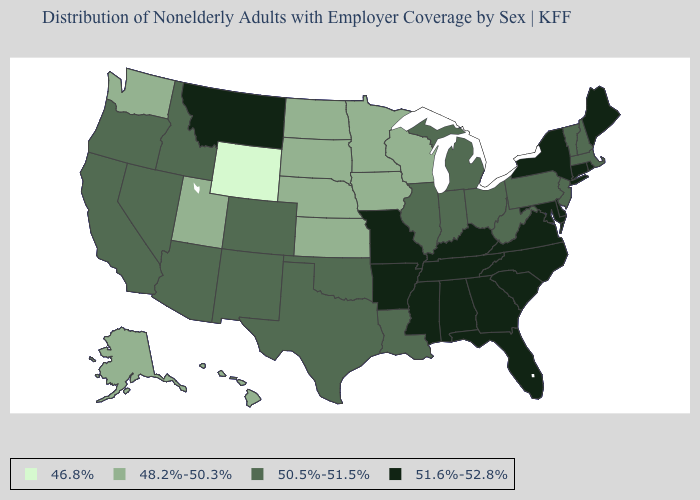Among the states that border Illinois , which have the lowest value?
Short answer required. Iowa, Wisconsin. Name the states that have a value in the range 51.6%-52.8%?
Short answer required. Alabama, Arkansas, Connecticut, Delaware, Florida, Georgia, Kentucky, Maine, Maryland, Mississippi, Missouri, Montana, New York, North Carolina, Rhode Island, South Carolina, Tennessee, Virginia. Among the states that border Virginia , does Maryland have the lowest value?
Be succinct. No. Is the legend a continuous bar?
Concise answer only. No. Does Maine have the lowest value in the Northeast?
Give a very brief answer. No. Among the states that border Virginia , which have the highest value?
Give a very brief answer. Kentucky, Maryland, North Carolina, Tennessee. Which states have the lowest value in the USA?
Be succinct. Wyoming. Name the states that have a value in the range 48.2%-50.3%?
Short answer required. Alaska, Hawaii, Iowa, Kansas, Minnesota, Nebraska, North Dakota, South Dakota, Utah, Washington, Wisconsin. Which states have the highest value in the USA?
Concise answer only. Alabama, Arkansas, Connecticut, Delaware, Florida, Georgia, Kentucky, Maine, Maryland, Mississippi, Missouri, Montana, New York, North Carolina, Rhode Island, South Carolina, Tennessee, Virginia. Which states have the lowest value in the Northeast?
Write a very short answer. Massachusetts, New Hampshire, New Jersey, Pennsylvania, Vermont. Which states have the highest value in the USA?
Keep it brief. Alabama, Arkansas, Connecticut, Delaware, Florida, Georgia, Kentucky, Maine, Maryland, Mississippi, Missouri, Montana, New York, North Carolina, Rhode Island, South Carolina, Tennessee, Virginia. Name the states that have a value in the range 50.5%-51.5%?
Concise answer only. Arizona, California, Colorado, Idaho, Illinois, Indiana, Louisiana, Massachusetts, Michigan, Nevada, New Hampshire, New Jersey, New Mexico, Ohio, Oklahoma, Oregon, Pennsylvania, Texas, Vermont, West Virginia. Which states have the highest value in the USA?
Answer briefly. Alabama, Arkansas, Connecticut, Delaware, Florida, Georgia, Kentucky, Maine, Maryland, Mississippi, Missouri, Montana, New York, North Carolina, Rhode Island, South Carolina, Tennessee, Virginia. Among the states that border Iowa , does Missouri have the highest value?
Quick response, please. Yes. Does Wyoming have the lowest value in the USA?
Keep it brief. Yes. 